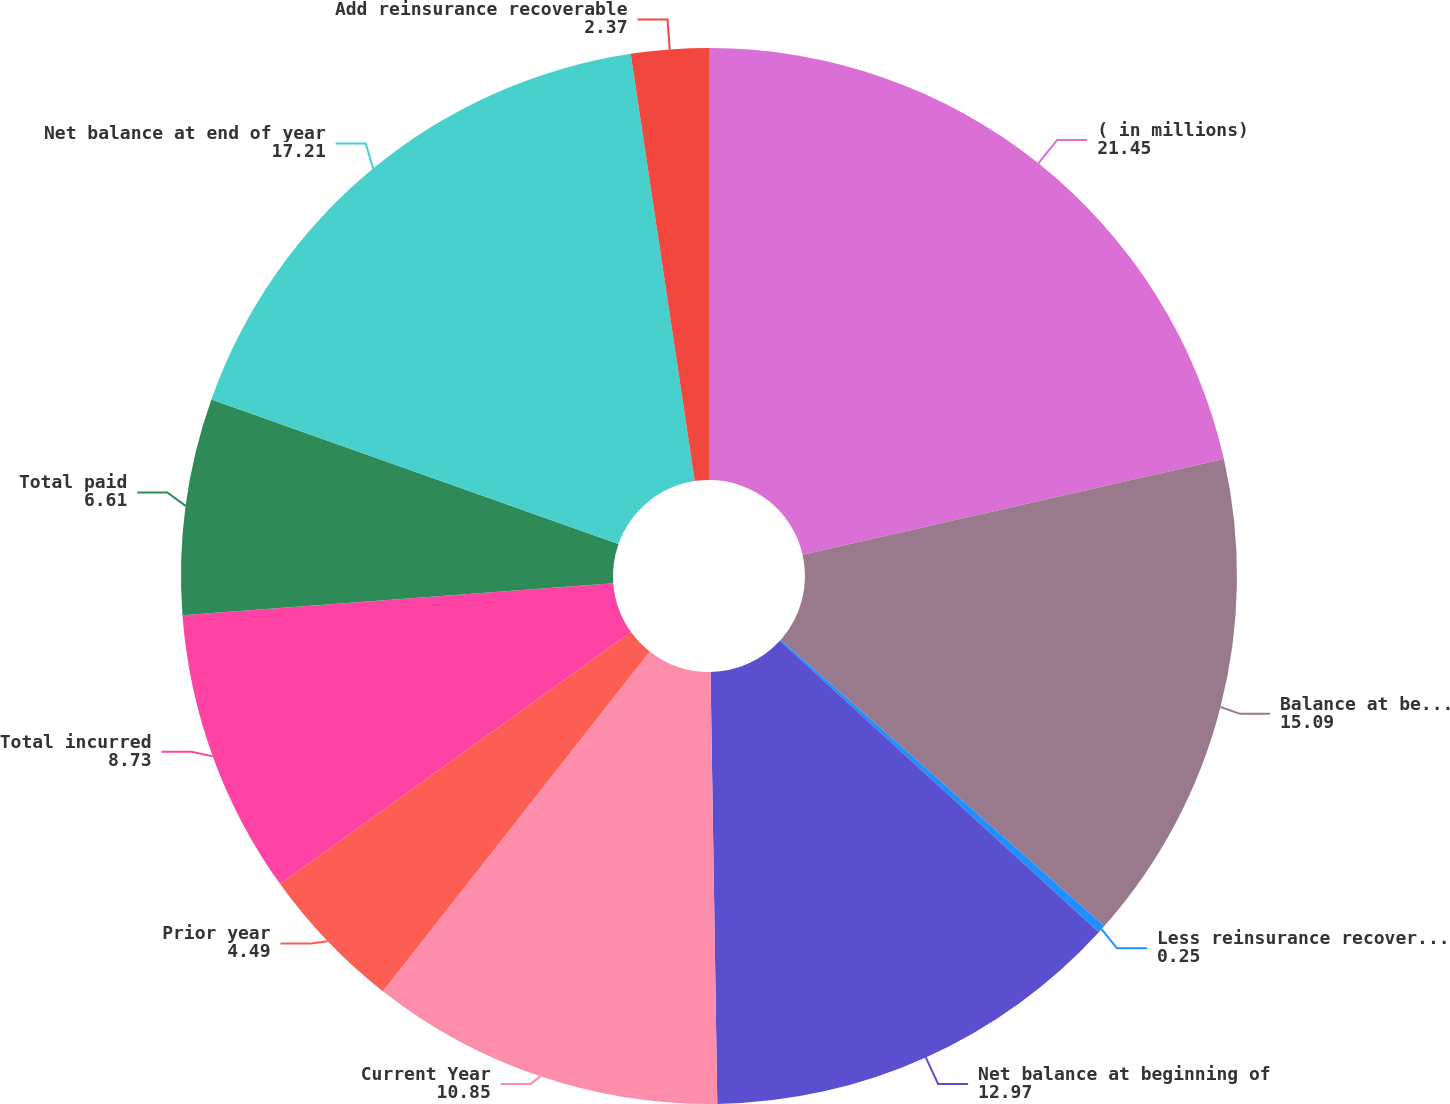<chart> <loc_0><loc_0><loc_500><loc_500><pie_chart><fcel>( in millions)<fcel>Balance at beginning of year<fcel>Less reinsurance recoverable<fcel>Net balance at beginning of<fcel>Current Year<fcel>Prior year<fcel>Total incurred<fcel>Total paid<fcel>Net balance at end of year<fcel>Add reinsurance recoverable<nl><fcel>21.45%<fcel>15.09%<fcel>0.25%<fcel>12.97%<fcel>10.85%<fcel>4.49%<fcel>8.73%<fcel>6.61%<fcel>17.21%<fcel>2.37%<nl></chart> 